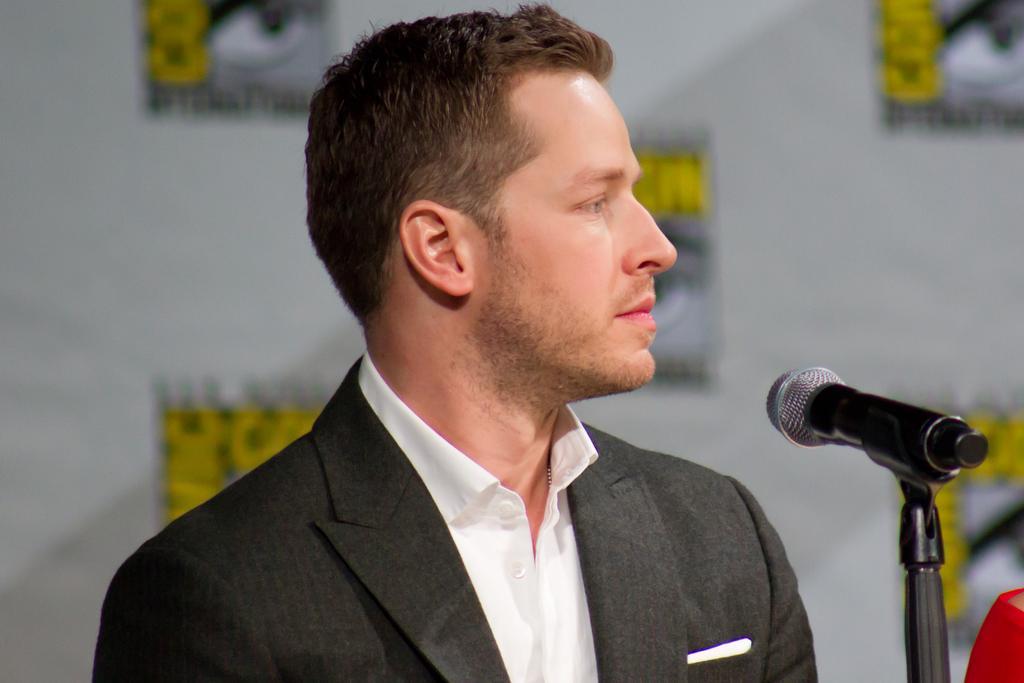Could you give a brief overview of what you see in this image? We can see a man at the mic which is on a stand. In the background there is a hoarding. 